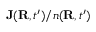<formula> <loc_0><loc_0><loc_500><loc_500>{ J } ( { R } , t ^ { \prime } ) / n ( { R } , t ^ { \prime } )</formula> 